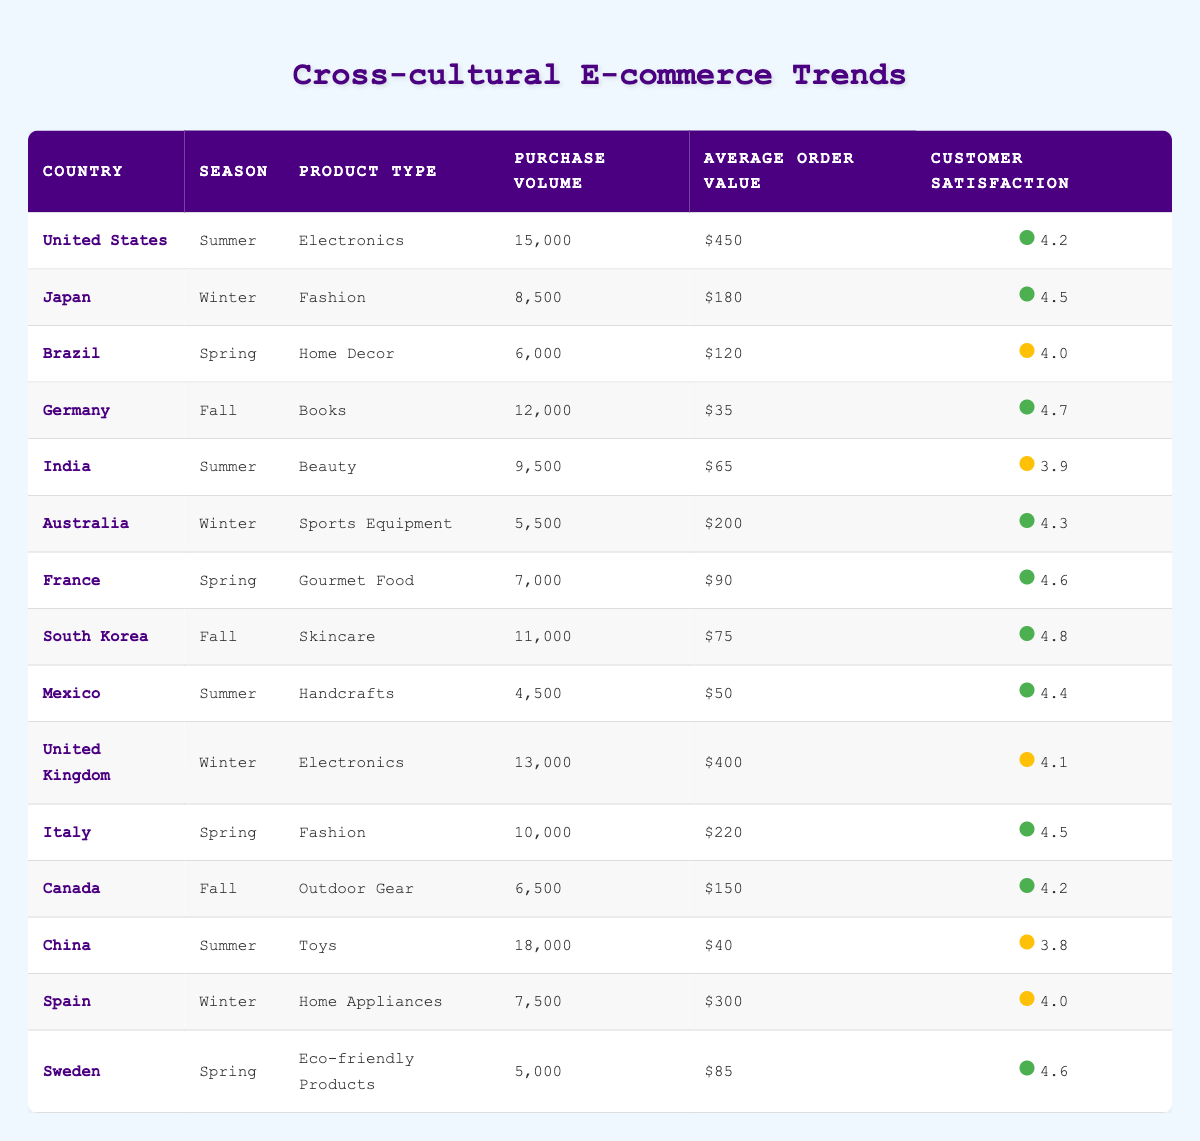What is the purchase volume for Fashion products in Japan during Winter? According to the table, the only entry for Japan in the Winter season relates to Fashion, which has a Purchase Volume of 8500.
Answer: 8500 Which country has the highest Average Order Value for Home Decor? Looking at the rows for Home Decor products, Brazil has an Average Order Value of 120, and it is the only country listed for that product type. Therefore, it also has the highest value.
Answer: 120 What is the total Purchase Volume for Summer season across all countries? Adding up the Purchase Volumes for Summer which are: United States (15000), India (9500), Mexico (4500), and China (18000). The total is 15000 + 9500 + 4500 + 18000 = 40000.
Answer: 40000 Is customer satisfaction for Skincare products in South Korea higher than that for Beauty products in India? South Korea has a Customer Satisfaction score of 4.8 for Skincare, while India has a score of 3.9 for Beauty. Since 4.8 is greater than 3.9, this statement is true.
Answer: Yes In which season does Germany achieve the highest Customer Satisfaction for Books? The entry for Germany during Fall lists a Customer Satisfaction score of 4.7 for Books, which is the only season listed, hence it's the highest for that product in Germany.
Answer: Fall What is the combined average of Average Order Value for Electronics in the United States and the United Kingdom? The Average Order Value for the United States is 450 and for the United Kingdom it is 400. Combining these yields 450 + 400 = 850. Now, calculating the average gives 850 / 2 = 425.
Answer: 425 Does Italy have a higher Purchase Volume for Fashion compared to Japan? Italy has a Purchase Volume of 10000 for Fashion in Spring, while Japan records 8500 for Fashion in Winter. Since 10000 is greater than 8500, the statement is true.
Answer: Yes How many countries have a Purchase Volume of more than 10000 for any product? Reviewing the table, the countries with Purchase Volumes greater than 10000 are: United States (15000), China (18000), South Korea (11000), which totals to 3 countries.
Answer: 3 What is the difference in Customer Satisfaction between Outdoor Gear in Canada and Home Appliances in Spain? Canada has a Customer Satisfaction score of 4.2 for Outdoor Gear and Spain has a score of 4.0 for Home Appliances. Calculating the difference yields 4.2 - 4.0 = 0.2.
Answer: 0.2 